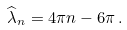Convert formula to latex. <formula><loc_0><loc_0><loc_500><loc_500>\widehat { \lambda } _ { n } = 4 \pi n - 6 \pi \, .</formula> 